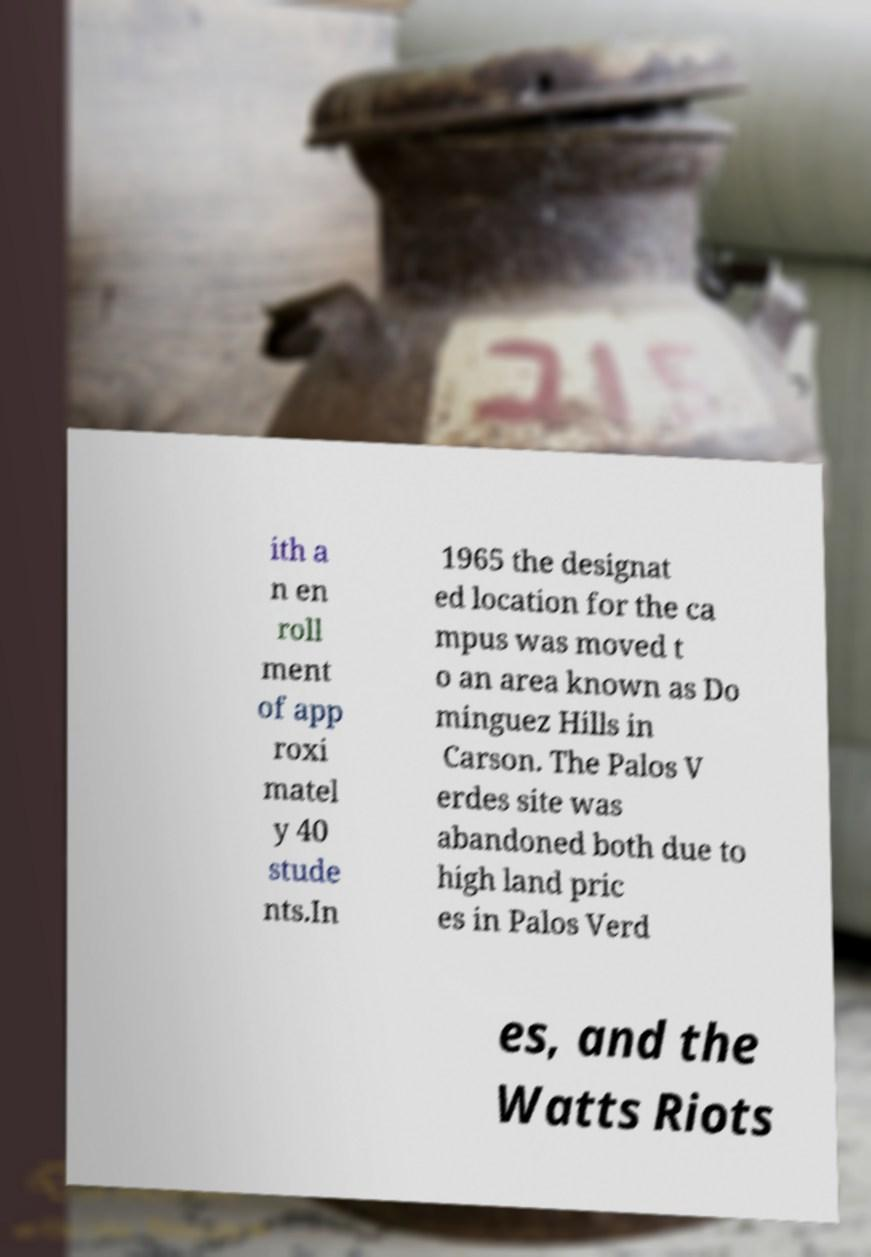Please identify and transcribe the text found in this image. ith a n en roll ment of app roxi matel y 40 stude nts.In 1965 the designat ed location for the ca mpus was moved t o an area known as Do minguez Hills in Carson. The Palos V erdes site was abandoned both due to high land pric es in Palos Verd es, and the Watts Riots 